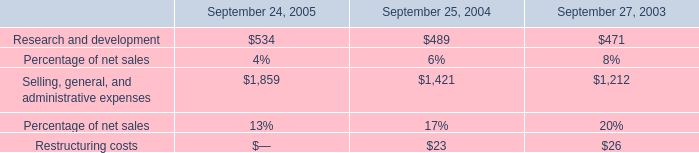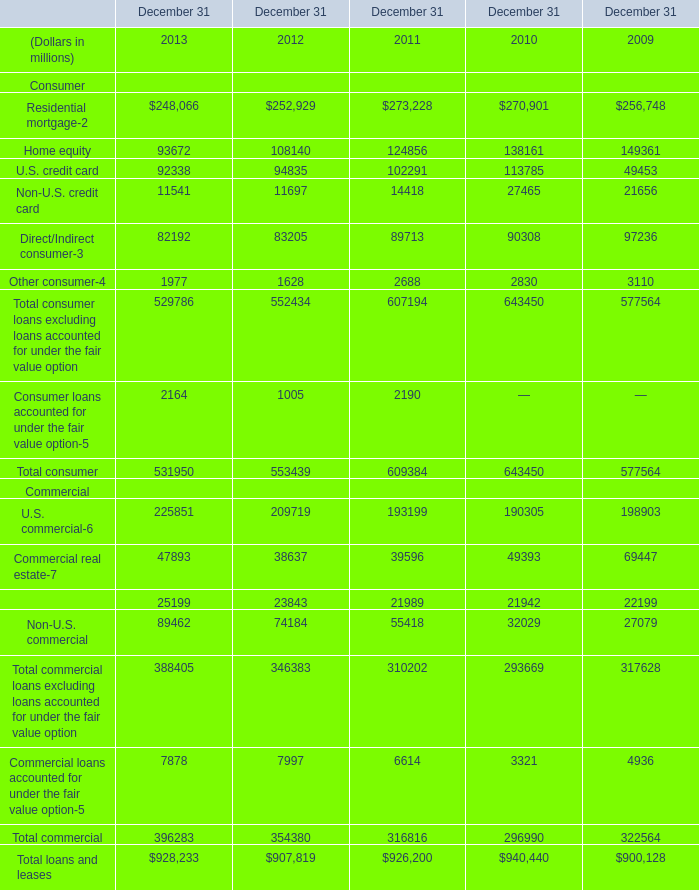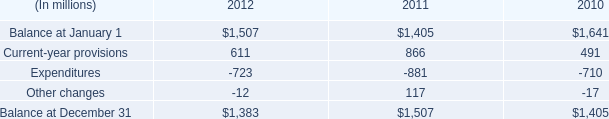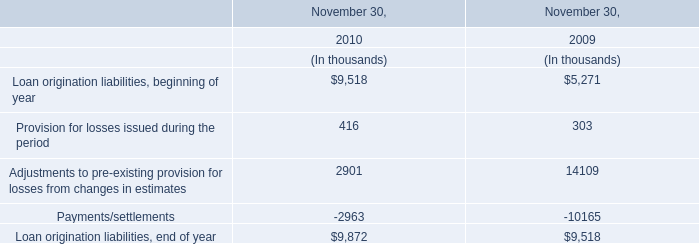What is the growing rate of Provision for losses issued during the period in Table 3 in the year with the most U.S. credit card in Table 1? 
Computations: ((416 - 303) / 303)
Answer: 0.37294. 